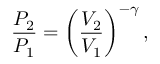Convert formula to latex. <formula><loc_0><loc_0><loc_500><loc_500>{ \frac { P _ { 2 } } { P _ { 1 } } } = \left ( { \frac { V _ { 2 } } { V _ { 1 } } } \right ) ^ { - \gamma } ,</formula> 